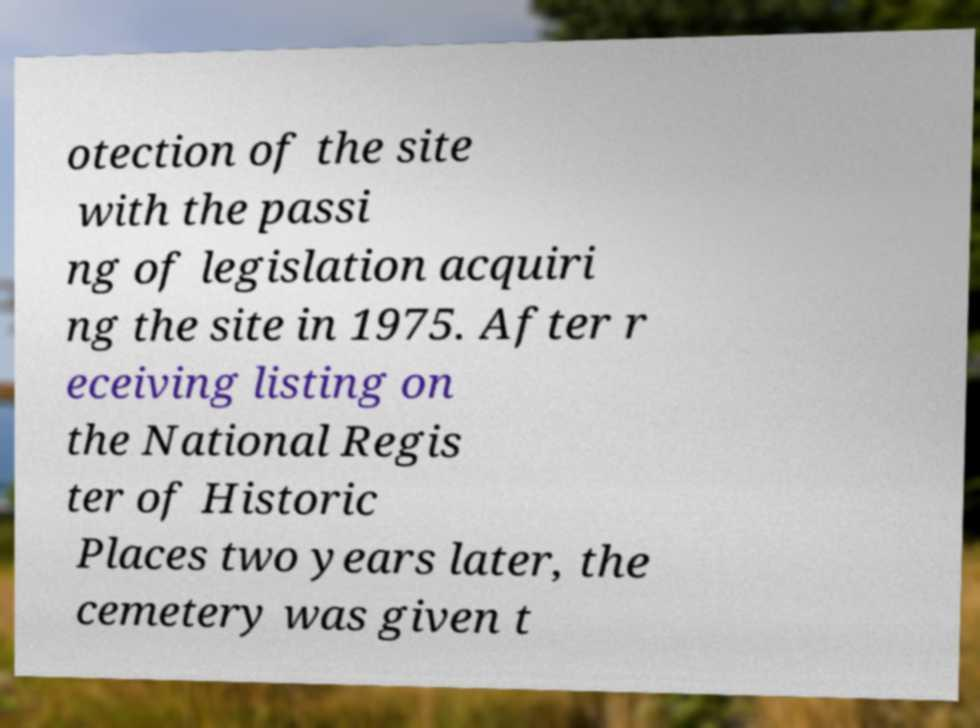I need the written content from this picture converted into text. Can you do that? otection of the site with the passi ng of legislation acquiri ng the site in 1975. After r eceiving listing on the National Regis ter of Historic Places two years later, the cemetery was given t 